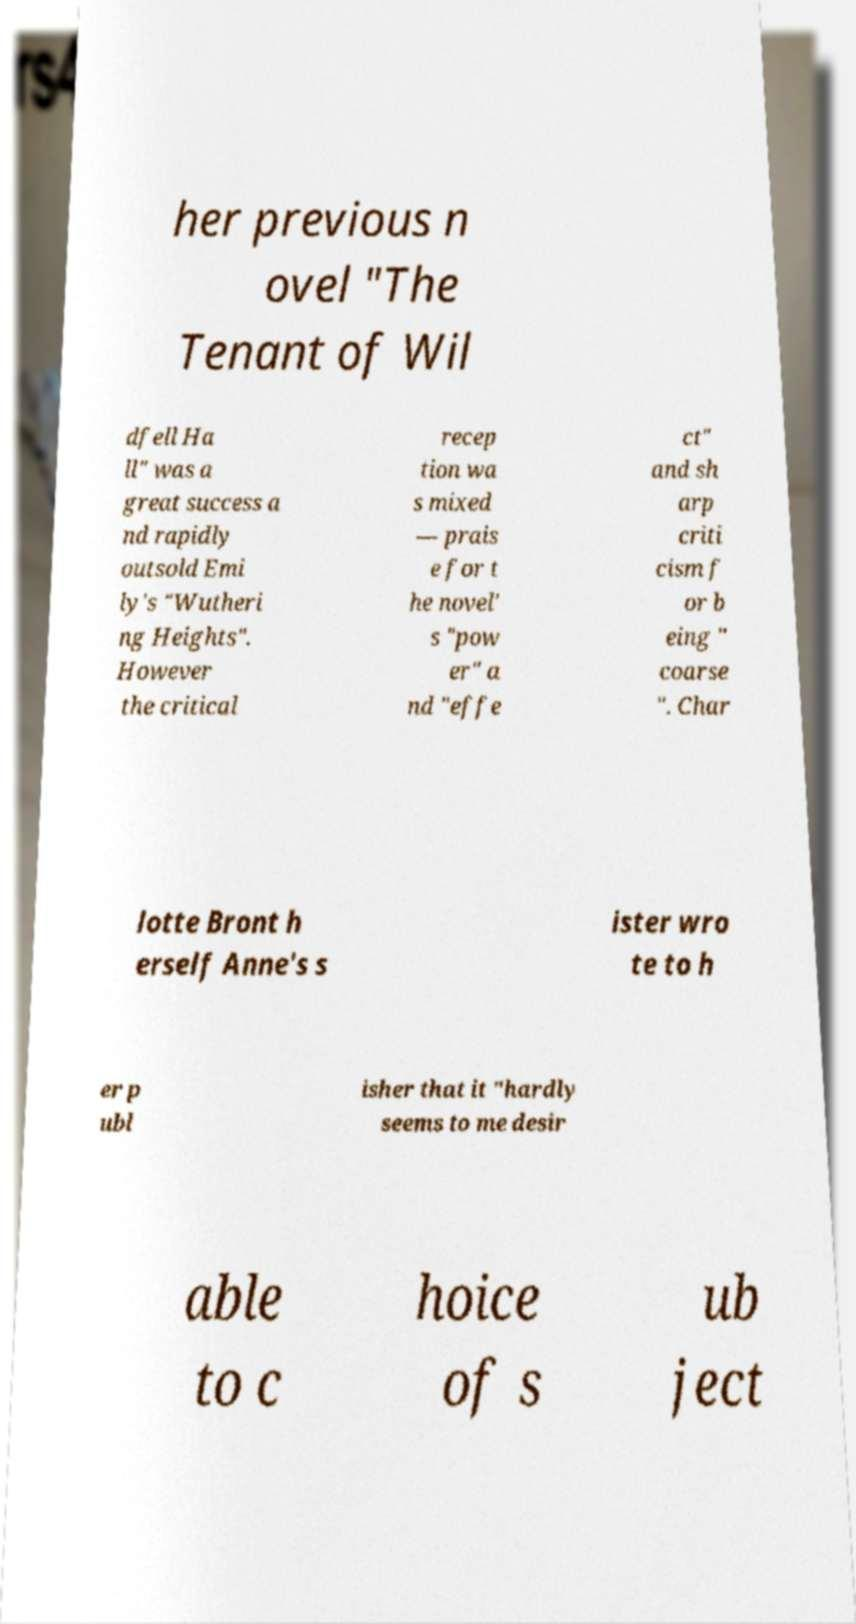Can you read and provide the text displayed in the image?This photo seems to have some interesting text. Can you extract and type it out for me? her previous n ovel "The Tenant of Wil dfell Ha ll" was a great success a nd rapidly outsold Emi ly's "Wutheri ng Heights". However the critical recep tion wa s mixed — prais e for t he novel' s "pow er" a nd "effe ct" and sh arp criti cism f or b eing " coarse ". Char lotte Bront h erself Anne's s ister wro te to h er p ubl isher that it "hardly seems to me desir able to c hoice of s ub ject 